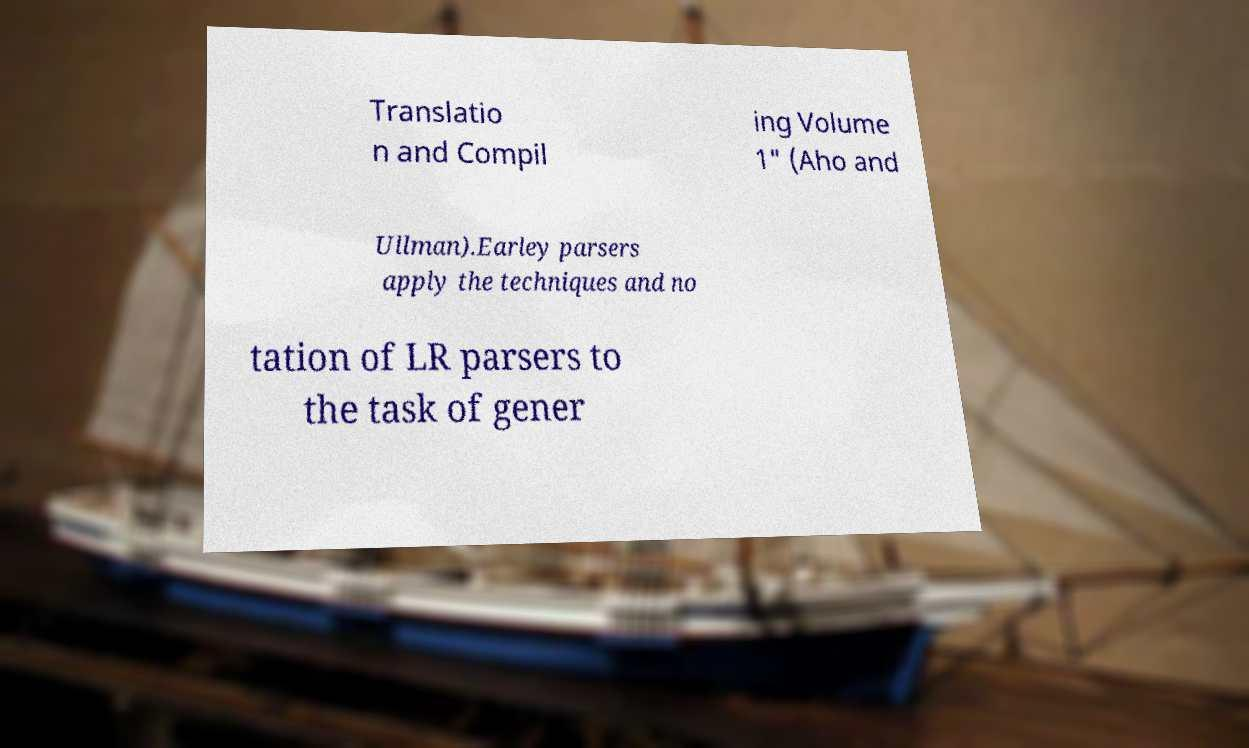Please read and relay the text visible in this image. What does it say? Translatio n and Compil ing Volume 1" (Aho and Ullman).Earley parsers apply the techniques and no tation of LR parsers to the task of gener 